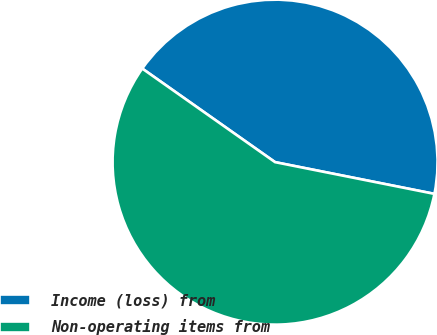Convert chart to OTSL. <chart><loc_0><loc_0><loc_500><loc_500><pie_chart><fcel>Income (loss) from<fcel>Non-operating items from<nl><fcel>43.36%<fcel>56.64%<nl></chart> 